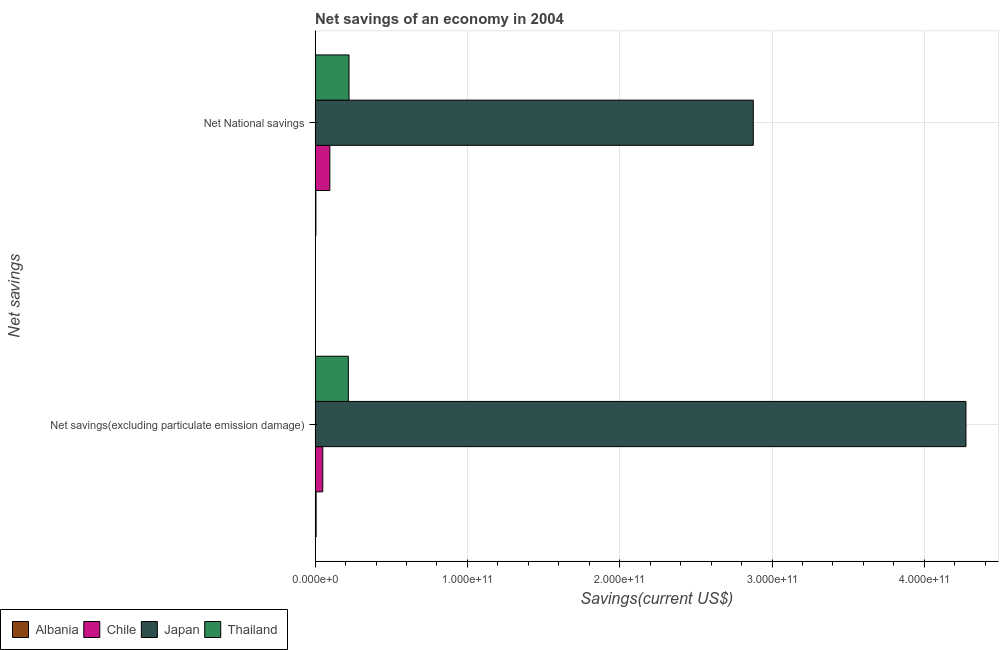Are the number of bars per tick equal to the number of legend labels?
Ensure brevity in your answer.  Yes. How many bars are there on the 1st tick from the top?
Ensure brevity in your answer.  4. How many bars are there on the 1st tick from the bottom?
Give a very brief answer. 4. What is the label of the 2nd group of bars from the top?
Your answer should be very brief. Net savings(excluding particulate emission damage). What is the net savings(excluding particulate emission damage) in Thailand?
Your answer should be compact. 2.18e+1. Across all countries, what is the maximum net national savings?
Your response must be concise. 2.88e+11. Across all countries, what is the minimum net national savings?
Ensure brevity in your answer.  5.31e+08. In which country was the net savings(excluding particulate emission damage) maximum?
Your response must be concise. Japan. In which country was the net national savings minimum?
Keep it short and to the point. Albania. What is the total net savings(excluding particulate emission damage) in the graph?
Your answer should be compact. 4.55e+11. What is the difference between the net national savings in Chile and that in Japan?
Your answer should be compact. -2.78e+11. What is the difference between the net savings(excluding particulate emission damage) in Japan and the net national savings in Albania?
Your answer should be very brief. 4.27e+11. What is the average net national savings per country?
Offer a terse response. 8.00e+1. What is the difference between the net savings(excluding particulate emission damage) and net national savings in Albania?
Ensure brevity in your answer.  1.44e+08. What is the ratio of the net savings(excluding particulate emission damage) in Thailand to that in Chile?
Offer a very short reply. 4.34. What does the 3rd bar from the top in Net National savings represents?
Your answer should be very brief. Chile. What does the 4th bar from the bottom in Net savings(excluding particulate emission damage) represents?
Keep it short and to the point. Thailand. How many countries are there in the graph?
Make the answer very short. 4. What is the difference between two consecutive major ticks on the X-axis?
Give a very brief answer. 1.00e+11. Where does the legend appear in the graph?
Your answer should be very brief. Bottom left. How many legend labels are there?
Keep it short and to the point. 4. What is the title of the graph?
Your answer should be very brief. Net savings of an economy in 2004. Does "Zambia" appear as one of the legend labels in the graph?
Make the answer very short. No. What is the label or title of the X-axis?
Your answer should be very brief. Savings(current US$). What is the label or title of the Y-axis?
Keep it short and to the point. Net savings. What is the Savings(current US$) of Albania in Net savings(excluding particulate emission damage)?
Your answer should be compact. 6.75e+08. What is the Savings(current US$) in Chile in Net savings(excluding particulate emission damage)?
Provide a succinct answer. 5.03e+09. What is the Savings(current US$) in Japan in Net savings(excluding particulate emission damage)?
Provide a short and direct response. 4.27e+11. What is the Savings(current US$) of Thailand in Net savings(excluding particulate emission damage)?
Ensure brevity in your answer.  2.18e+1. What is the Savings(current US$) of Albania in Net National savings?
Ensure brevity in your answer.  5.31e+08. What is the Savings(current US$) in Chile in Net National savings?
Give a very brief answer. 9.67e+09. What is the Savings(current US$) of Japan in Net National savings?
Your response must be concise. 2.88e+11. What is the Savings(current US$) of Thailand in Net National savings?
Offer a very short reply. 2.23e+1. Across all Net savings, what is the maximum Savings(current US$) of Albania?
Give a very brief answer. 6.75e+08. Across all Net savings, what is the maximum Savings(current US$) in Chile?
Provide a short and direct response. 9.67e+09. Across all Net savings, what is the maximum Savings(current US$) in Japan?
Offer a terse response. 4.27e+11. Across all Net savings, what is the maximum Savings(current US$) in Thailand?
Ensure brevity in your answer.  2.23e+1. Across all Net savings, what is the minimum Savings(current US$) of Albania?
Give a very brief answer. 5.31e+08. Across all Net savings, what is the minimum Savings(current US$) in Chile?
Provide a succinct answer. 5.03e+09. Across all Net savings, what is the minimum Savings(current US$) of Japan?
Your answer should be compact. 2.88e+11. Across all Net savings, what is the minimum Savings(current US$) in Thailand?
Your response must be concise. 2.18e+1. What is the total Savings(current US$) in Albania in the graph?
Keep it short and to the point. 1.21e+09. What is the total Savings(current US$) in Chile in the graph?
Offer a very short reply. 1.47e+1. What is the total Savings(current US$) of Japan in the graph?
Keep it short and to the point. 7.15e+11. What is the total Savings(current US$) in Thailand in the graph?
Make the answer very short. 4.41e+1. What is the difference between the Savings(current US$) in Albania in Net savings(excluding particulate emission damage) and that in Net National savings?
Your response must be concise. 1.44e+08. What is the difference between the Savings(current US$) in Chile in Net savings(excluding particulate emission damage) and that in Net National savings?
Give a very brief answer. -4.64e+09. What is the difference between the Savings(current US$) of Japan in Net savings(excluding particulate emission damage) and that in Net National savings?
Your answer should be compact. 1.40e+11. What is the difference between the Savings(current US$) in Thailand in Net savings(excluding particulate emission damage) and that in Net National savings?
Provide a succinct answer. -4.63e+08. What is the difference between the Savings(current US$) in Albania in Net savings(excluding particulate emission damage) and the Savings(current US$) in Chile in Net National savings?
Your answer should be very brief. -8.99e+09. What is the difference between the Savings(current US$) in Albania in Net savings(excluding particulate emission damage) and the Savings(current US$) in Japan in Net National savings?
Give a very brief answer. -2.87e+11. What is the difference between the Savings(current US$) of Albania in Net savings(excluding particulate emission damage) and the Savings(current US$) of Thailand in Net National savings?
Offer a very short reply. -2.16e+1. What is the difference between the Savings(current US$) in Chile in Net savings(excluding particulate emission damage) and the Savings(current US$) in Japan in Net National savings?
Your response must be concise. -2.83e+11. What is the difference between the Savings(current US$) in Chile in Net savings(excluding particulate emission damage) and the Savings(current US$) in Thailand in Net National savings?
Offer a terse response. -1.72e+1. What is the difference between the Savings(current US$) in Japan in Net savings(excluding particulate emission damage) and the Savings(current US$) in Thailand in Net National savings?
Your response must be concise. 4.05e+11. What is the average Savings(current US$) in Albania per Net savings?
Your answer should be very brief. 6.03e+08. What is the average Savings(current US$) of Chile per Net savings?
Your answer should be compact. 7.35e+09. What is the average Savings(current US$) in Japan per Net savings?
Keep it short and to the point. 3.58e+11. What is the average Savings(current US$) of Thailand per Net savings?
Provide a short and direct response. 2.20e+1. What is the difference between the Savings(current US$) in Albania and Savings(current US$) in Chile in Net savings(excluding particulate emission damage)?
Offer a very short reply. -4.35e+09. What is the difference between the Savings(current US$) of Albania and Savings(current US$) of Japan in Net savings(excluding particulate emission damage)?
Provide a short and direct response. -4.27e+11. What is the difference between the Savings(current US$) of Albania and Savings(current US$) of Thailand in Net savings(excluding particulate emission damage)?
Your answer should be compact. -2.11e+1. What is the difference between the Savings(current US$) of Chile and Savings(current US$) of Japan in Net savings(excluding particulate emission damage)?
Make the answer very short. -4.22e+11. What is the difference between the Savings(current US$) of Chile and Savings(current US$) of Thailand in Net savings(excluding particulate emission damage)?
Your response must be concise. -1.68e+1. What is the difference between the Savings(current US$) in Japan and Savings(current US$) in Thailand in Net savings(excluding particulate emission damage)?
Offer a terse response. 4.06e+11. What is the difference between the Savings(current US$) of Albania and Savings(current US$) of Chile in Net National savings?
Your answer should be very brief. -9.14e+09. What is the difference between the Savings(current US$) in Albania and Savings(current US$) in Japan in Net National savings?
Offer a terse response. -2.87e+11. What is the difference between the Savings(current US$) of Albania and Savings(current US$) of Thailand in Net National savings?
Give a very brief answer. -2.17e+1. What is the difference between the Savings(current US$) of Chile and Savings(current US$) of Japan in Net National savings?
Give a very brief answer. -2.78e+11. What is the difference between the Savings(current US$) in Chile and Savings(current US$) in Thailand in Net National savings?
Your answer should be compact. -1.26e+1. What is the difference between the Savings(current US$) of Japan and Savings(current US$) of Thailand in Net National savings?
Provide a short and direct response. 2.65e+11. What is the ratio of the Savings(current US$) in Albania in Net savings(excluding particulate emission damage) to that in Net National savings?
Provide a succinct answer. 1.27. What is the ratio of the Savings(current US$) in Chile in Net savings(excluding particulate emission damage) to that in Net National savings?
Make the answer very short. 0.52. What is the ratio of the Savings(current US$) in Japan in Net savings(excluding particulate emission damage) to that in Net National savings?
Provide a short and direct response. 1.49. What is the ratio of the Savings(current US$) in Thailand in Net savings(excluding particulate emission damage) to that in Net National savings?
Offer a very short reply. 0.98. What is the difference between the highest and the second highest Savings(current US$) of Albania?
Your answer should be compact. 1.44e+08. What is the difference between the highest and the second highest Savings(current US$) of Chile?
Offer a very short reply. 4.64e+09. What is the difference between the highest and the second highest Savings(current US$) of Japan?
Ensure brevity in your answer.  1.40e+11. What is the difference between the highest and the second highest Savings(current US$) in Thailand?
Provide a short and direct response. 4.63e+08. What is the difference between the highest and the lowest Savings(current US$) of Albania?
Offer a very short reply. 1.44e+08. What is the difference between the highest and the lowest Savings(current US$) of Chile?
Your answer should be very brief. 4.64e+09. What is the difference between the highest and the lowest Savings(current US$) of Japan?
Your answer should be very brief. 1.40e+11. What is the difference between the highest and the lowest Savings(current US$) in Thailand?
Provide a short and direct response. 4.63e+08. 